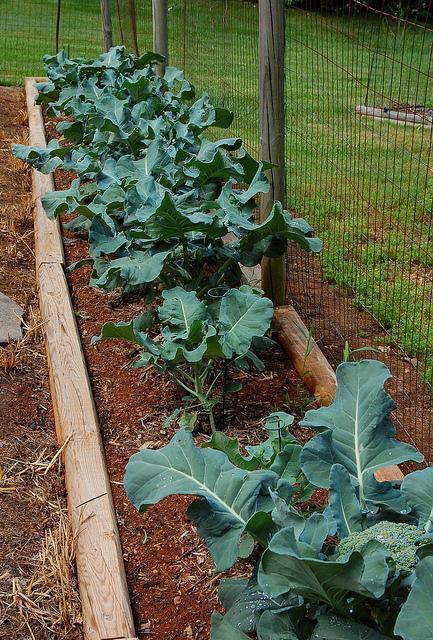How many red flowers?
Give a very brief answer. 0. How many sections in the garden?
Give a very brief answer. 1. How many broccolis are in the picture?
Give a very brief answer. 2. 